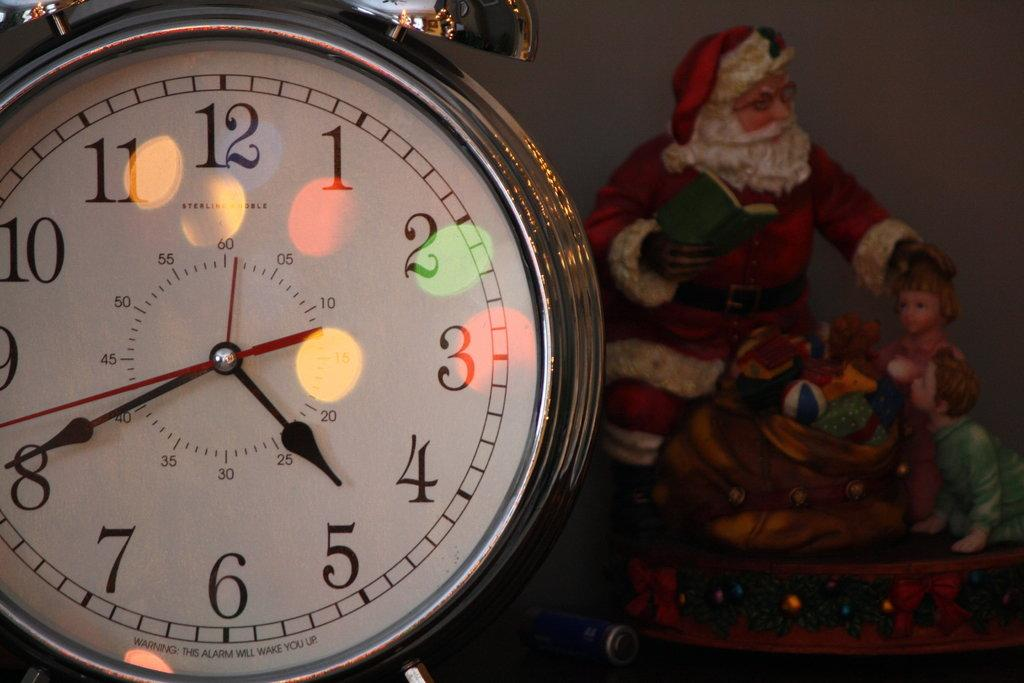Provide a one-sentence caption for the provided image. The small hand of a watch sits between the numbers 4 and 5. 